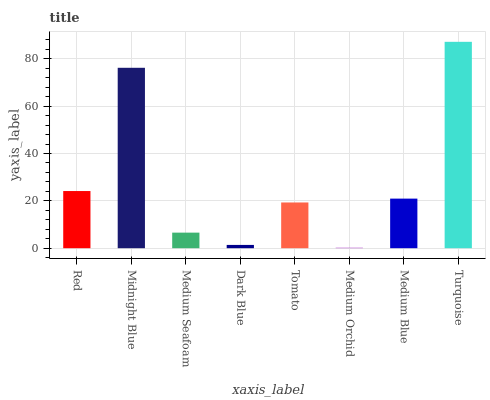Is Medium Orchid the minimum?
Answer yes or no. Yes. Is Turquoise the maximum?
Answer yes or no. Yes. Is Midnight Blue the minimum?
Answer yes or no. No. Is Midnight Blue the maximum?
Answer yes or no. No. Is Midnight Blue greater than Red?
Answer yes or no. Yes. Is Red less than Midnight Blue?
Answer yes or no. Yes. Is Red greater than Midnight Blue?
Answer yes or no. No. Is Midnight Blue less than Red?
Answer yes or no. No. Is Medium Blue the high median?
Answer yes or no. Yes. Is Tomato the low median?
Answer yes or no. Yes. Is Dark Blue the high median?
Answer yes or no. No. Is Medium Blue the low median?
Answer yes or no. No. 